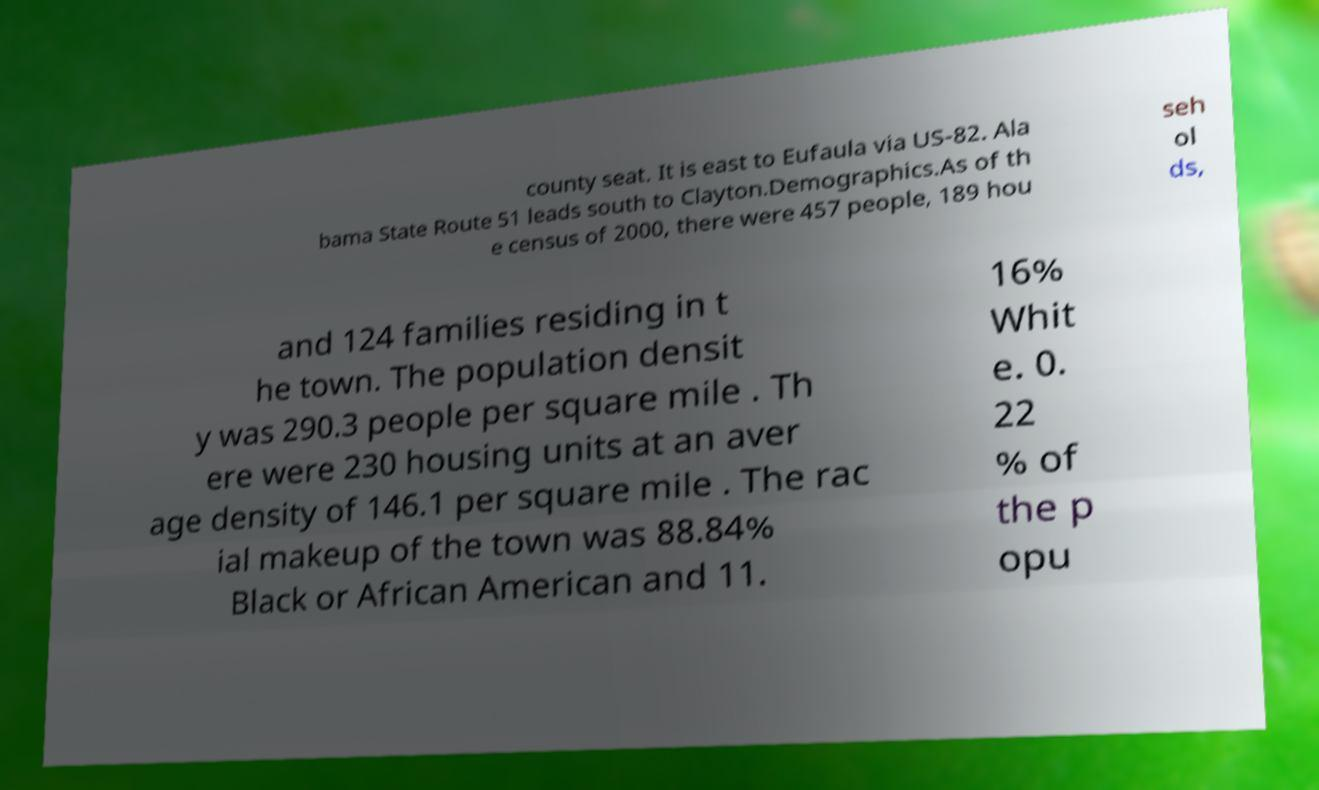Please read and relay the text visible in this image. What does it say? county seat. It is east to Eufaula via US-82. Ala bama State Route 51 leads south to Clayton.Demographics.As of th e census of 2000, there were 457 people, 189 hou seh ol ds, and 124 families residing in t he town. The population densit y was 290.3 people per square mile . Th ere were 230 housing units at an aver age density of 146.1 per square mile . The rac ial makeup of the town was 88.84% Black or African American and 11. 16% Whit e. 0. 22 % of the p opu 